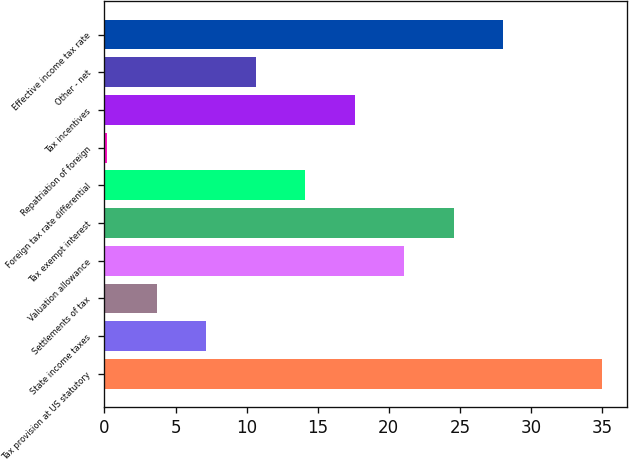Convert chart. <chart><loc_0><loc_0><loc_500><loc_500><bar_chart><fcel>Tax provision at US statutory<fcel>State income taxes<fcel>Settlements of tax<fcel>Valuation allowance<fcel>Tax exempt interest<fcel>Foreign tax rate differential<fcel>Repatriation of foreign<fcel>Tax incentives<fcel>Other - net<fcel>Effective income tax rate<nl><fcel>35<fcel>7.16<fcel>3.68<fcel>21.08<fcel>24.56<fcel>14.12<fcel>0.2<fcel>17.6<fcel>10.64<fcel>28.04<nl></chart> 